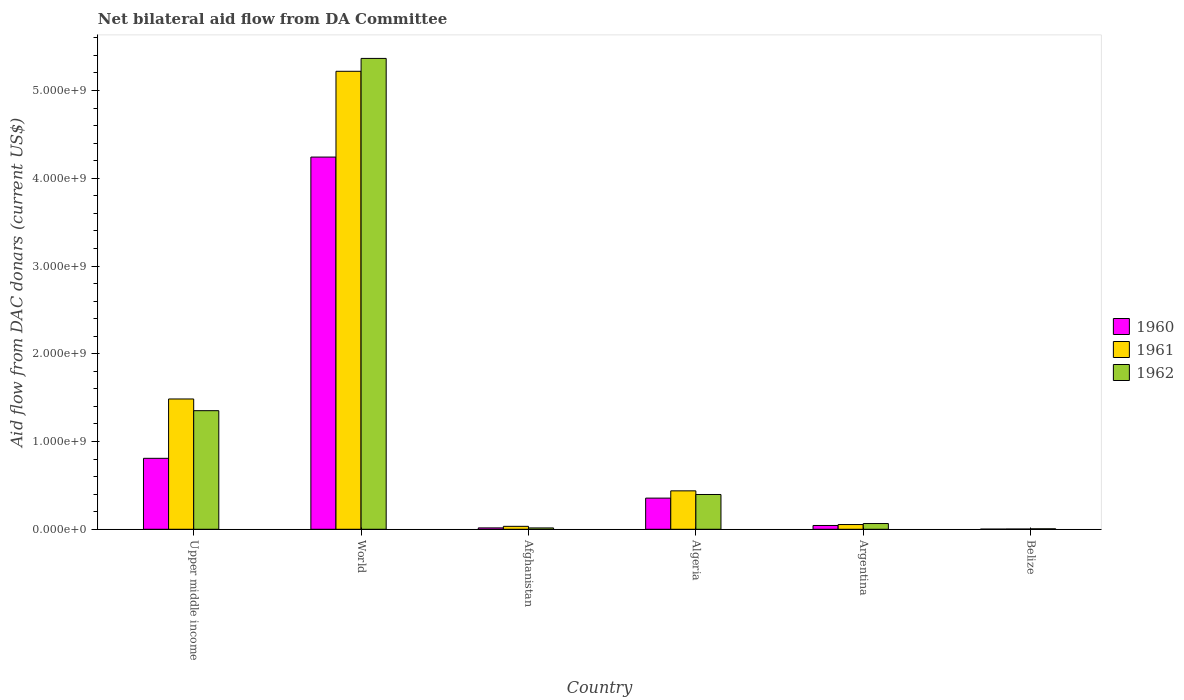How many groups of bars are there?
Your answer should be very brief. 6. Are the number of bars per tick equal to the number of legend labels?
Your response must be concise. Yes. Are the number of bars on each tick of the X-axis equal?
Your answer should be very brief. Yes. How many bars are there on the 5th tick from the right?
Make the answer very short. 3. What is the label of the 6th group of bars from the left?
Keep it short and to the point. Belize. In how many cases, is the number of bars for a given country not equal to the number of legend labels?
Offer a terse response. 0. What is the aid flow in in 1960 in World?
Provide a succinct answer. 4.24e+09. Across all countries, what is the maximum aid flow in in 1960?
Your answer should be very brief. 4.24e+09. Across all countries, what is the minimum aid flow in in 1962?
Your answer should be compact. 5.39e+06. In which country was the aid flow in in 1962 maximum?
Your response must be concise. World. In which country was the aid flow in in 1962 minimum?
Provide a short and direct response. Belize. What is the total aid flow in in 1962 in the graph?
Ensure brevity in your answer.  7.20e+09. What is the difference between the aid flow in in 1962 in Upper middle income and that in World?
Your response must be concise. -4.01e+09. What is the difference between the aid flow in in 1961 in Upper middle income and the aid flow in in 1960 in Algeria?
Offer a terse response. 1.13e+09. What is the average aid flow in in 1962 per country?
Your response must be concise. 1.20e+09. What is the difference between the aid flow in of/in 1961 and aid flow in of/in 1962 in Upper middle income?
Your response must be concise. 1.34e+08. What is the ratio of the aid flow in in 1961 in Argentina to that in Belize?
Give a very brief answer. 19.41. Is the aid flow in in 1962 in Afghanistan less than that in Belize?
Your answer should be compact. No. What is the difference between the highest and the second highest aid flow in in 1961?
Your answer should be very brief. 3.73e+09. What is the difference between the highest and the lowest aid flow in in 1962?
Keep it short and to the point. 5.36e+09. In how many countries, is the aid flow in in 1962 greater than the average aid flow in in 1962 taken over all countries?
Provide a short and direct response. 2. Is the sum of the aid flow in in 1962 in Algeria and Belize greater than the maximum aid flow in in 1961 across all countries?
Offer a very short reply. No. Is it the case that in every country, the sum of the aid flow in in 1961 and aid flow in in 1960 is greater than the aid flow in in 1962?
Offer a very short reply. No. How many bars are there?
Give a very brief answer. 18. What is the difference between two consecutive major ticks on the Y-axis?
Make the answer very short. 1.00e+09. Does the graph contain any zero values?
Ensure brevity in your answer.  No. Does the graph contain grids?
Ensure brevity in your answer.  No. Where does the legend appear in the graph?
Offer a very short reply. Center right. How many legend labels are there?
Provide a short and direct response. 3. What is the title of the graph?
Provide a short and direct response. Net bilateral aid flow from DA Committee. Does "1999" appear as one of the legend labels in the graph?
Give a very brief answer. No. What is the label or title of the X-axis?
Keep it short and to the point. Country. What is the label or title of the Y-axis?
Offer a terse response. Aid flow from DAC donars (current US$). What is the Aid flow from DAC donars (current US$) in 1960 in Upper middle income?
Make the answer very short. 8.09e+08. What is the Aid flow from DAC donars (current US$) in 1961 in Upper middle income?
Your answer should be very brief. 1.48e+09. What is the Aid flow from DAC donars (current US$) in 1962 in Upper middle income?
Ensure brevity in your answer.  1.35e+09. What is the Aid flow from DAC donars (current US$) in 1960 in World?
Keep it short and to the point. 4.24e+09. What is the Aid flow from DAC donars (current US$) of 1961 in World?
Your answer should be compact. 5.22e+09. What is the Aid flow from DAC donars (current US$) in 1962 in World?
Offer a terse response. 5.37e+09. What is the Aid flow from DAC donars (current US$) of 1960 in Afghanistan?
Offer a very short reply. 1.57e+07. What is the Aid flow from DAC donars (current US$) of 1961 in Afghanistan?
Your response must be concise. 3.36e+07. What is the Aid flow from DAC donars (current US$) in 1962 in Afghanistan?
Your answer should be very brief. 1.53e+07. What is the Aid flow from DAC donars (current US$) of 1960 in Algeria?
Keep it short and to the point. 3.55e+08. What is the Aid flow from DAC donars (current US$) in 1961 in Algeria?
Offer a very short reply. 4.38e+08. What is the Aid flow from DAC donars (current US$) in 1962 in Algeria?
Provide a succinct answer. 3.96e+08. What is the Aid flow from DAC donars (current US$) in 1960 in Argentina?
Provide a succinct answer. 4.32e+07. What is the Aid flow from DAC donars (current US$) of 1961 in Argentina?
Offer a very short reply. 5.40e+07. What is the Aid flow from DAC donars (current US$) in 1962 in Argentina?
Give a very brief answer. 6.53e+07. What is the Aid flow from DAC donars (current US$) in 1960 in Belize?
Ensure brevity in your answer.  1.80e+06. What is the Aid flow from DAC donars (current US$) of 1961 in Belize?
Provide a succinct answer. 2.78e+06. What is the Aid flow from DAC donars (current US$) of 1962 in Belize?
Give a very brief answer. 5.39e+06. Across all countries, what is the maximum Aid flow from DAC donars (current US$) of 1960?
Keep it short and to the point. 4.24e+09. Across all countries, what is the maximum Aid flow from DAC donars (current US$) of 1961?
Your answer should be very brief. 5.22e+09. Across all countries, what is the maximum Aid flow from DAC donars (current US$) in 1962?
Your answer should be very brief. 5.37e+09. Across all countries, what is the minimum Aid flow from DAC donars (current US$) in 1960?
Provide a short and direct response. 1.80e+06. Across all countries, what is the minimum Aid flow from DAC donars (current US$) of 1961?
Provide a succinct answer. 2.78e+06. Across all countries, what is the minimum Aid flow from DAC donars (current US$) of 1962?
Give a very brief answer. 5.39e+06. What is the total Aid flow from DAC donars (current US$) of 1960 in the graph?
Make the answer very short. 5.47e+09. What is the total Aid flow from DAC donars (current US$) of 1961 in the graph?
Provide a succinct answer. 7.23e+09. What is the total Aid flow from DAC donars (current US$) of 1962 in the graph?
Your response must be concise. 7.20e+09. What is the difference between the Aid flow from DAC donars (current US$) of 1960 in Upper middle income and that in World?
Offer a terse response. -3.43e+09. What is the difference between the Aid flow from DAC donars (current US$) of 1961 in Upper middle income and that in World?
Offer a terse response. -3.73e+09. What is the difference between the Aid flow from DAC donars (current US$) of 1962 in Upper middle income and that in World?
Your answer should be compact. -4.01e+09. What is the difference between the Aid flow from DAC donars (current US$) of 1960 in Upper middle income and that in Afghanistan?
Provide a succinct answer. 7.93e+08. What is the difference between the Aid flow from DAC donars (current US$) of 1961 in Upper middle income and that in Afghanistan?
Provide a succinct answer. 1.45e+09. What is the difference between the Aid flow from DAC donars (current US$) in 1962 in Upper middle income and that in Afghanistan?
Give a very brief answer. 1.34e+09. What is the difference between the Aid flow from DAC donars (current US$) in 1960 in Upper middle income and that in Algeria?
Offer a very short reply. 4.53e+08. What is the difference between the Aid flow from DAC donars (current US$) of 1961 in Upper middle income and that in Algeria?
Provide a succinct answer. 1.05e+09. What is the difference between the Aid flow from DAC donars (current US$) of 1962 in Upper middle income and that in Algeria?
Your answer should be very brief. 9.55e+08. What is the difference between the Aid flow from DAC donars (current US$) of 1960 in Upper middle income and that in Argentina?
Your answer should be compact. 7.65e+08. What is the difference between the Aid flow from DAC donars (current US$) in 1961 in Upper middle income and that in Argentina?
Offer a very short reply. 1.43e+09. What is the difference between the Aid flow from DAC donars (current US$) in 1962 in Upper middle income and that in Argentina?
Your answer should be compact. 1.29e+09. What is the difference between the Aid flow from DAC donars (current US$) of 1960 in Upper middle income and that in Belize?
Offer a very short reply. 8.07e+08. What is the difference between the Aid flow from DAC donars (current US$) of 1961 in Upper middle income and that in Belize?
Your answer should be very brief. 1.48e+09. What is the difference between the Aid flow from DAC donars (current US$) of 1962 in Upper middle income and that in Belize?
Offer a terse response. 1.35e+09. What is the difference between the Aid flow from DAC donars (current US$) in 1960 in World and that in Afghanistan?
Offer a very short reply. 4.23e+09. What is the difference between the Aid flow from DAC donars (current US$) of 1961 in World and that in Afghanistan?
Offer a very short reply. 5.19e+09. What is the difference between the Aid flow from DAC donars (current US$) of 1962 in World and that in Afghanistan?
Give a very brief answer. 5.35e+09. What is the difference between the Aid flow from DAC donars (current US$) of 1960 in World and that in Algeria?
Provide a succinct answer. 3.89e+09. What is the difference between the Aid flow from DAC donars (current US$) of 1961 in World and that in Algeria?
Your answer should be very brief. 4.78e+09. What is the difference between the Aid flow from DAC donars (current US$) in 1962 in World and that in Algeria?
Ensure brevity in your answer.  4.97e+09. What is the difference between the Aid flow from DAC donars (current US$) in 1960 in World and that in Argentina?
Provide a succinct answer. 4.20e+09. What is the difference between the Aid flow from DAC donars (current US$) in 1961 in World and that in Argentina?
Give a very brief answer. 5.17e+09. What is the difference between the Aid flow from DAC donars (current US$) in 1962 in World and that in Argentina?
Provide a succinct answer. 5.30e+09. What is the difference between the Aid flow from DAC donars (current US$) of 1960 in World and that in Belize?
Your answer should be compact. 4.24e+09. What is the difference between the Aid flow from DAC donars (current US$) in 1961 in World and that in Belize?
Give a very brief answer. 5.22e+09. What is the difference between the Aid flow from DAC donars (current US$) of 1962 in World and that in Belize?
Your answer should be compact. 5.36e+09. What is the difference between the Aid flow from DAC donars (current US$) in 1960 in Afghanistan and that in Algeria?
Provide a short and direct response. -3.39e+08. What is the difference between the Aid flow from DAC donars (current US$) in 1961 in Afghanistan and that in Algeria?
Your answer should be compact. -4.04e+08. What is the difference between the Aid flow from DAC donars (current US$) in 1962 in Afghanistan and that in Algeria?
Your answer should be very brief. -3.81e+08. What is the difference between the Aid flow from DAC donars (current US$) in 1960 in Afghanistan and that in Argentina?
Your answer should be compact. -2.75e+07. What is the difference between the Aid flow from DAC donars (current US$) of 1961 in Afghanistan and that in Argentina?
Your answer should be compact. -2.04e+07. What is the difference between the Aid flow from DAC donars (current US$) in 1962 in Afghanistan and that in Argentina?
Give a very brief answer. -5.00e+07. What is the difference between the Aid flow from DAC donars (current US$) of 1960 in Afghanistan and that in Belize?
Provide a succinct answer. 1.39e+07. What is the difference between the Aid flow from DAC donars (current US$) in 1961 in Afghanistan and that in Belize?
Provide a succinct answer. 3.08e+07. What is the difference between the Aid flow from DAC donars (current US$) of 1962 in Afghanistan and that in Belize?
Provide a succinct answer. 9.87e+06. What is the difference between the Aid flow from DAC donars (current US$) of 1960 in Algeria and that in Argentina?
Keep it short and to the point. 3.12e+08. What is the difference between the Aid flow from DAC donars (current US$) of 1961 in Algeria and that in Argentina?
Provide a succinct answer. 3.84e+08. What is the difference between the Aid flow from DAC donars (current US$) of 1962 in Algeria and that in Argentina?
Offer a terse response. 3.31e+08. What is the difference between the Aid flow from DAC donars (current US$) in 1960 in Algeria and that in Belize?
Ensure brevity in your answer.  3.53e+08. What is the difference between the Aid flow from DAC donars (current US$) of 1961 in Algeria and that in Belize?
Your response must be concise. 4.35e+08. What is the difference between the Aid flow from DAC donars (current US$) of 1962 in Algeria and that in Belize?
Your answer should be very brief. 3.91e+08. What is the difference between the Aid flow from DAC donars (current US$) of 1960 in Argentina and that in Belize?
Provide a succinct answer. 4.14e+07. What is the difference between the Aid flow from DAC donars (current US$) of 1961 in Argentina and that in Belize?
Keep it short and to the point. 5.12e+07. What is the difference between the Aid flow from DAC donars (current US$) of 1962 in Argentina and that in Belize?
Your answer should be very brief. 5.99e+07. What is the difference between the Aid flow from DAC donars (current US$) of 1960 in Upper middle income and the Aid flow from DAC donars (current US$) of 1961 in World?
Your answer should be very brief. -4.41e+09. What is the difference between the Aid flow from DAC donars (current US$) of 1960 in Upper middle income and the Aid flow from DAC donars (current US$) of 1962 in World?
Your answer should be compact. -4.56e+09. What is the difference between the Aid flow from DAC donars (current US$) of 1961 in Upper middle income and the Aid flow from DAC donars (current US$) of 1962 in World?
Your answer should be very brief. -3.88e+09. What is the difference between the Aid flow from DAC donars (current US$) in 1960 in Upper middle income and the Aid flow from DAC donars (current US$) in 1961 in Afghanistan?
Your answer should be very brief. 7.75e+08. What is the difference between the Aid flow from DAC donars (current US$) in 1960 in Upper middle income and the Aid flow from DAC donars (current US$) in 1962 in Afghanistan?
Keep it short and to the point. 7.93e+08. What is the difference between the Aid flow from DAC donars (current US$) of 1961 in Upper middle income and the Aid flow from DAC donars (current US$) of 1962 in Afghanistan?
Provide a short and direct response. 1.47e+09. What is the difference between the Aid flow from DAC donars (current US$) in 1960 in Upper middle income and the Aid flow from DAC donars (current US$) in 1961 in Algeria?
Offer a terse response. 3.71e+08. What is the difference between the Aid flow from DAC donars (current US$) in 1960 in Upper middle income and the Aid flow from DAC donars (current US$) in 1962 in Algeria?
Provide a succinct answer. 4.12e+08. What is the difference between the Aid flow from DAC donars (current US$) in 1961 in Upper middle income and the Aid flow from DAC donars (current US$) in 1962 in Algeria?
Give a very brief answer. 1.09e+09. What is the difference between the Aid flow from DAC donars (current US$) of 1960 in Upper middle income and the Aid flow from DAC donars (current US$) of 1961 in Argentina?
Provide a succinct answer. 7.55e+08. What is the difference between the Aid flow from DAC donars (current US$) in 1960 in Upper middle income and the Aid flow from DAC donars (current US$) in 1962 in Argentina?
Your response must be concise. 7.43e+08. What is the difference between the Aid flow from DAC donars (current US$) of 1961 in Upper middle income and the Aid flow from DAC donars (current US$) of 1962 in Argentina?
Offer a very short reply. 1.42e+09. What is the difference between the Aid flow from DAC donars (current US$) in 1960 in Upper middle income and the Aid flow from DAC donars (current US$) in 1961 in Belize?
Give a very brief answer. 8.06e+08. What is the difference between the Aid flow from DAC donars (current US$) in 1960 in Upper middle income and the Aid flow from DAC donars (current US$) in 1962 in Belize?
Your answer should be very brief. 8.03e+08. What is the difference between the Aid flow from DAC donars (current US$) of 1961 in Upper middle income and the Aid flow from DAC donars (current US$) of 1962 in Belize?
Make the answer very short. 1.48e+09. What is the difference between the Aid flow from DAC donars (current US$) of 1960 in World and the Aid flow from DAC donars (current US$) of 1961 in Afghanistan?
Your response must be concise. 4.21e+09. What is the difference between the Aid flow from DAC donars (current US$) of 1960 in World and the Aid flow from DAC donars (current US$) of 1962 in Afghanistan?
Provide a succinct answer. 4.23e+09. What is the difference between the Aid flow from DAC donars (current US$) in 1961 in World and the Aid flow from DAC donars (current US$) in 1962 in Afghanistan?
Give a very brief answer. 5.20e+09. What is the difference between the Aid flow from DAC donars (current US$) in 1960 in World and the Aid flow from DAC donars (current US$) in 1961 in Algeria?
Provide a succinct answer. 3.80e+09. What is the difference between the Aid flow from DAC donars (current US$) of 1960 in World and the Aid flow from DAC donars (current US$) of 1962 in Algeria?
Give a very brief answer. 3.85e+09. What is the difference between the Aid flow from DAC donars (current US$) in 1961 in World and the Aid flow from DAC donars (current US$) in 1962 in Algeria?
Keep it short and to the point. 4.82e+09. What is the difference between the Aid flow from DAC donars (current US$) of 1960 in World and the Aid flow from DAC donars (current US$) of 1961 in Argentina?
Offer a very short reply. 4.19e+09. What is the difference between the Aid flow from DAC donars (current US$) of 1960 in World and the Aid flow from DAC donars (current US$) of 1962 in Argentina?
Your response must be concise. 4.18e+09. What is the difference between the Aid flow from DAC donars (current US$) in 1961 in World and the Aid flow from DAC donars (current US$) in 1962 in Argentina?
Make the answer very short. 5.15e+09. What is the difference between the Aid flow from DAC donars (current US$) in 1960 in World and the Aid flow from DAC donars (current US$) in 1961 in Belize?
Keep it short and to the point. 4.24e+09. What is the difference between the Aid flow from DAC donars (current US$) in 1960 in World and the Aid flow from DAC donars (current US$) in 1962 in Belize?
Your answer should be compact. 4.24e+09. What is the difference between the Aid flow from DAC donars (current US$) of 1961 in World and the Aid flow from DAC donars (current US$) of 1962 in Belize?
Make the answer very short. 5.21e+09. What is the difference between the Aid flow from DAC donars (current US$) of 1960 in Afghanistan and the Aid flow from DAC donars (current US$) of 1961 in Algeria?
Offer a very short reply. -4.22e+08. What is the difference between the Aid flow from DAC donars (current US$) of 1960 in Afghanistan and the Aid flow from DAC donars (current US$) of 1962 in Algeria?
Keep it short and to the point. -3.81e+08. What is the difference between the Aid flow from DAC donars (current US$) in 1961 in Afghanistan and the Aid flow from DAC donars (current US$) in 1962 in Algeria?
Make the answer very short. -3.63e+08. What is the difference between the Aid flow from DAC donars (current US$) in 1960 in Afghanistan and the Aid flow from DAC donars (current US$) in 1961 in Argentina?
Ensure brevity in your answer.  -3.83e+07. What is the difference between the Aid flow from DAC donars (current US$) of 1960 in Afghanistan and the Aid flow from DAC donars (current US$) of 1962 in Argentina?
Provide a succinct answer. -4.96e+07. What is the difference between the Aid flow from DAC donars (current US$) of 1961 in Afghanistan and the Aid flow from DAC donars (current US$) of 1962 in Argentina?
Offer a very short reply. -3.17e+07. What is the difference between the Aid flow from DAC donars (current US$) in 1960 in Afghanistan and the Aid flow from DAC donars (current US$) in 1961 in Belize?
Ensure brevity in your answer.  1.29e+07. What is the difference between the Aid flow from DAC donars (current US$) of 1960 in Afghanistan and the Aid flow from DAC donars (current US$) of 1962 in Belize?
Your response must be concise. 1.03e+07. What is the difference between the Aid flow from DAC donars (current US$) in 1961 in Afghanistan and the Aid flow from DAC donars (current US$) in 1962 in Belize?
Your answer should be compact. 2.82e+07. What is the difference between the Aid flow from DAC donars (current US$) of 1960 in Algeria and the Aid flow from DAC donars (current US$) of 1961 in Argentina?
Make the answer very short. 3.01e+08. What is the difference between the Aid flow from DAC donars (current US$) in 1960 in Algeria and the Aid flow from DAC donars (current US$) in 1962 in Argentina?
Your answer should be very brief. 2.90e+08. What is the difference between the Aid flow from DAC donars (current US$) in 1961 in Algeria and the Aid flow from DAC donars (current US$) in 1962 in Argentina?
Your answer should be compact. 3.73e+08. What is the difference between the Aid flow from DAC donars (current US$) of 1960 in Algeria and the Aid flow from DAC donars (current US$) of 1961 in Belize?
Your response must be concise. 3.52e+08. What is the difference between the Aid flow from DAC donars (current US$) in 1960 in Algeria and the Aid flow from DAC donars (current US$) in 1962 in Belize?
Provide a succinct answer. 3.50e+08. What is the difference between the Aid flow from DAC donars (current US$) of 1961 in Algeria and the Aid flow from DAC donars (current US$) of 1962 in Belize?
Provide a succinct answer. 4.33e+08. What is the difference between the Aid flow from DAC donars (current US$) of 1960 in Argentina and the Aid flow from DAC donars (current US$) of 1961 in Belize?
Your response must be concise. 4.04e+07. What is the difference between the Aid flow from DAC donars (current US$) in 1960 in Argentina and the Aid flow from DAC donars (current US$) in 1962 in Belize?
Offer a terse response. 3.78e+07. What is the difference between the Aid flow from DAC donars (current US$) in 1961 in Argentina and the Aid flow from DAC donars (current US$) in 1962 in Belize?
Keep it short and to the point. 4.86e+07. What is the average Aid flow from DAC donars (current US$) of 1960 per country?
Give a very brief answer. 9.11e+08. What is the average Aid flow from DAC donars (current US$) in 1961 per country?
Give a very brief answer. 1.21e+09. What is the average Aid flow from DAC donars (current US$) in 1962 per country?
Provide a succinct answer. 1.20e+09. What is the difference between the Aid flow from DAC donars (current US$) of 1960 and Aid flow from DAC donars (current US$) of 1961 in Upper middle income?
Ensure brevity in your answer.  -6.76e+08. What is the difference between the Aid flow from DAC donars (current US$) of 1960 and Aid flow from DAC donars (current US$) of 1962 in Upper middle income?
Offer a terse response. -5.43e+08. What is the difference between the Aid flow from DAC donars (current US$) of 1961 and Aid flow from DAC donars (current US$) of 1962 in Upper middle income?
Offer a terse response. 1.34e+08. What is the difference between the Aid flow from DAC donars (current US$) of 1960 and Aid flow from DAC donars (current US$) of 1961 in World?
Your response must be concise. -9.78e+08. What is the difference between the Aid flow from DAC donars (current US$) of 1960 and Aid flow from DAC donars (current US$) of 1962 in World?
Your answer should be compact. -1.12e+09. What is the difference between the Aid flow from DAC donars (current US$) in 1961 and Aid flow from DAC donars (current US$) in 1962 in World?
Keep it short and to the point. -1.47e+08. What is the difference between the Aid flow from DAC donars (current US$) in 1960 and Aid flow from DAC donars (current US$) in 1961 in Afghanistan?
Your response must be concise. -1.79e+07. What is the difference between the Aid flow from DAC donars (current US$) of 1961 and Aid flow from DAC donars (current US$) of 1962 in Afghanistan?
Give a very brief answer. 1.83e+07. What is the difference between the Aid flow from DAC donars (current US$) of 1960 and Aid flow from DAC donars (current US$) of 1961 in Algeria?
Provide a succinct answer. -8.28e+07. What is the difference between the Aid flow from DAC donars (current US$) of 1960 and Aid flow from DAC donars (current US$) of 1962 in Algeria?
Provide a succinct answer. -4.12e+07. What is the difference between the Aid flow from DAC donars (current US$) in 1961 and Aid flow from DAC donars (current US$) in 1962 in Algeria?
Provide a short and direct response. 4.16e+07. What is the difference between the Aid flow from DAC donars (current US$) in 1960 and Aid flow from DAC donars (current US$) in 1961 in Argentina?
Ensure brevity in your answer.  -1.07e+07. What is the difference between the Aid flow from DAC donars (current US$) of 1960 and Aid flow from DAC donars (current US$) of 1962 in Argentina?
Offer a terse response. -2.21e+07. What is the difference between the Aid flow from DAC donars (current US$) of 1961 and Aid flow from DAC donars (current US$) of 1962 in Argentina?
Ensure brevity in your answer.  -1.13e+07. What is the difference between the Aid flow from DAC donars (current US$) of 1960 and Aid flow from DAC donars (current US$) of 1961 in Belize?
Your answer should be compact. -9.80e+05. What is the difference between the Aid flow from DAC donars (current US$) of 1960 and Aid flow from DAC donars (current US$) of 1962 in Belize?
Give a very brief answer. -3.59e+06. What is the difference between the Aid flow from DAC donars (current US$) in 1961 and Aid flow from DAC donars (current US$) in 1962 in Belize?
Keep it short and to the point. -2.61e+06. What is the ratio of the Aid flow from DAC donars (current US$) in 1960 in Upper middle income to that in World?
Offer a terse response. 0.19. What is the ratio of the Aid flow from DAC donars (current US$) in 1961 in Upper middle income to that in World?
Offer a very short reply. 0.28. What is the ratio of the Aid flow from DAC donars (current US$) of 1962 in Upper middle income to that in World?
Keep it short and to the point. 0.25. What is the ratio of the Aid flow from DAC donars (current US$) in 1960 in Upper middle income to that in Afghanistan?
Make the answer very short. 51.6. What is the ratio of the Aid flow from DAC donars (current US$) in 1961 in Upper middle income to that in Afghanistan?
Offer a very short reply. 44.26. What is the ratio of the Aid flow from DAC donars (current US$) of 1962 in Upper middle income to that in Afghanistan?
Ensure brevity in your answer.  88.56. What is the ratio of the Aid flow from DAC donars (current US$) of 1960 in Upper middle income to that in Algeria?
Your answer should be compact. 2.28. What is the ratio of the Aid flow from DAC donars (current US$) in 1961 in Upper middle income to that in Algeria?
Offer a very short reply. 3.39. What is the ratio of the Aid flow from DAC donars (current US$) in 1962 in Upper middle income to that in Algeria?
Your answer should be compact. 3.41. What is the ratio of the Aid flow from DAC donars (current US$) in 1960 in Upper middle income to that in Argentina?
Offer a terse response. 18.71. What is the ratio of the Aid flow from DAC donars (current US$) in 1961 in Upper middle income to that in Argentina?
Your answer should be compact. 27.52. What is the ratio of the Aid flow from DAC donars (current US$) of 1962 in Upper middle income to that in Argentina?
Offer a terse response. 20.7. What is the ratio of the Aid flow from DAC donars (current US$) in 1960 in Upper middle income to that in Belize?
Offer a terse response. 449.17. What is the ratio of the Aid flow from DAC donars (current US$) of 1961 in Upper middle income to that in Belize?
Ensure brevity in your answer.  534.13. What is the ratio of the Aid flow from DAC donars (current US$) of 1962 in Upper middle income to that in Belize?
Provide a short and direct response. 250.72. What is the ratio of the Aid flow from DAC donars (current US$) in 1960 in World to that in Afghanistan?
Provide a succinct answer. 270.67. What is the ratio of the Aid flow from DAC donars (current US$) of 1961 in World to that in Afghanistan?
Offer a terse response. 155.56. What is the ratio of the Aid flow from DAC donars (current US$) of 1962 in World to that in Afghanistan?
Your answer should be very brief. 351.61. What is the ratio of the Aid flow from DAC donars (current US$) of 1960 in World to that in Algeria?
Ensure brevity in your answer.  11.94. What is the ratio of the Aid flow from DAC donars (current US$) of 1961 in World to that in Algeria?
Your answer should be compact. 11.92. What is the ratio of the Aid flow from DAC donars (current US$) in 1962 in World to that in Algeria?
Your answer should be compact. 13.54. What is the ratio of the Aid flow from DAC donars (current US$) of 1960 in World to that in Argentina?
Provide a succinct answer. 98.16. What is the ratio of the Aid flow from DAC donars (current US$) of 1961 in World to that in Argentina?
Offer a very short reply. 96.74. What is the ratio of the Aid flow from DAC donars (current US$) of 1962 in World to that in Argentina?
Make the answer very short. 82.18. What is the ratio of the Aid flow from DAC donars (current US$) in 1960 in World to that in Belize?
Your answer should be compact. 2356.36. What is the ratio of the Aid flow from DAC donars (current US$) of 1961 in World to that in Belize?
Give a very brief answer. 1877.34. What is the ratio of the Aid flow from DAC donars (current US$) in 1962 in World to that in Belize?
Provide a succinct answer. 995.48. What is the ratio of the Aid flow from DAC donars (current US$) of 1960 in Afghanistan to that in Algeria?
Your answer should be compact. 0.04. What is the ratio of the Aid flow from DAC donars (current US$) of 1961 in Afghanistan to that in Algeria?
Provide a succinct answer. 0.08. What is the ratio of the Aid flow from DAC donars (current US$) of 1962 in Afghanistan to that in Algeria?
Ensure brevity in your answer.  0.04. What is the ratio of the Aid flow from DAC donars (current US$) in 1960 in Afghanistan to that in Argentina?
Make the answer very short. 0.36. What is the ratio of the Aid flow from DAC donars (current US$) of 1961 in Afghanistan to that in Argentina?
Keep it short and to the point. 0.62. What is the ratio of the Aid flow from DAC donars (current US$) in 1962 in Afghanistan to that in Argentina?
Offer a very short reply. 0.23. What is the ratio of the Aid flow from DAC donars (current US$) in 1960 in Afghanistan to that in Belize?
Make the answer very short. 8.71. What is the ratio of the Aid flow from DAC donars (current US$) in 1961 in Afghanistan to that in Belize?
Keep it short and to the point. 12.07. What is the ratio of the Aid flow from DAC donars (current US$) of 1962 in Afghanistan to that in Belize?
Give a very brief answer. 2.83. What is the ratio of the Aid flow from DAC donars (current US$) of 1960 in Algeria to that in Argentina?
Provide a short and direct response. 8.22. What is the ratio of the Aid flow from DAC donars (current US$) of 1961 in Algeria to that in Argentina?
Provide a short and direct response. 8.12. What is the ratio of the Aid flow from DAC donars (current US$) in 1962 in Algeria to that in Argentina?
Give a very brief answer. 6.07. What is the ratio of the Aid flow from DAC donars (current US$) in 1960 in Algeria to that in Belize?
Provide a short and direct response. 197.28. What is the ratio of the Aid flow from DAC donars (current US$) in 1961 in Algeria to that in Belize?
Your answer should be very brief. 157.52. What is the ratio of the Aid flow from DAC donars (current US$) in 1962 in Algeria to that in Belize?
Provide a succinct answer. 73.53. What is the ratio of the Aid flow from DAC donars (current US$) in 1960 in Argentina to that in Belize?
Give a very brief answer. 24.01. What is the ratio of the Aid flow from DAC donars (current US$) in 1961 in Argentina to that in Belize?
Offer a very short reply. 19.41. What is the ratio of the Aid flow from DAC donars (current US$) of 1962 in Argentina to that in Belize?
Your answer should be very brief. 12.11. What is the difference between the highest and the second highest Aid flow from DAC donars (current US$) of 1960?
Offer a very short reply. 3.43e+09. What is the difference between the highest and the second highest Aid flow from DAC donars (current US$) of 1961?
Keep it short and to the point. 3.73e+09. What is the difference between the highest and the second highest Aid flow from DAC donars (current US$) in 1962?
Provide a short and direct response. 4.01e+09. What is the difference between the highest and the lowest Aid flow from DAC donars (current US$) of 1960?
Make the answer very short. 4.24e+09. What is the difference between the highest and the lowest Aid flow from DAC donars (current US$) of 1961?
Offer a very short reply. 5.22e+09. What is the difference between the highest and the lowest Aid flow from DAC donars (current US$) of 1962?
Ensure brevity in your answer.  5.36e+09. 